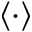<formula> <loc_0><loc_0><loc_500><loc_500>\langle \cdot \rangle</formula> 